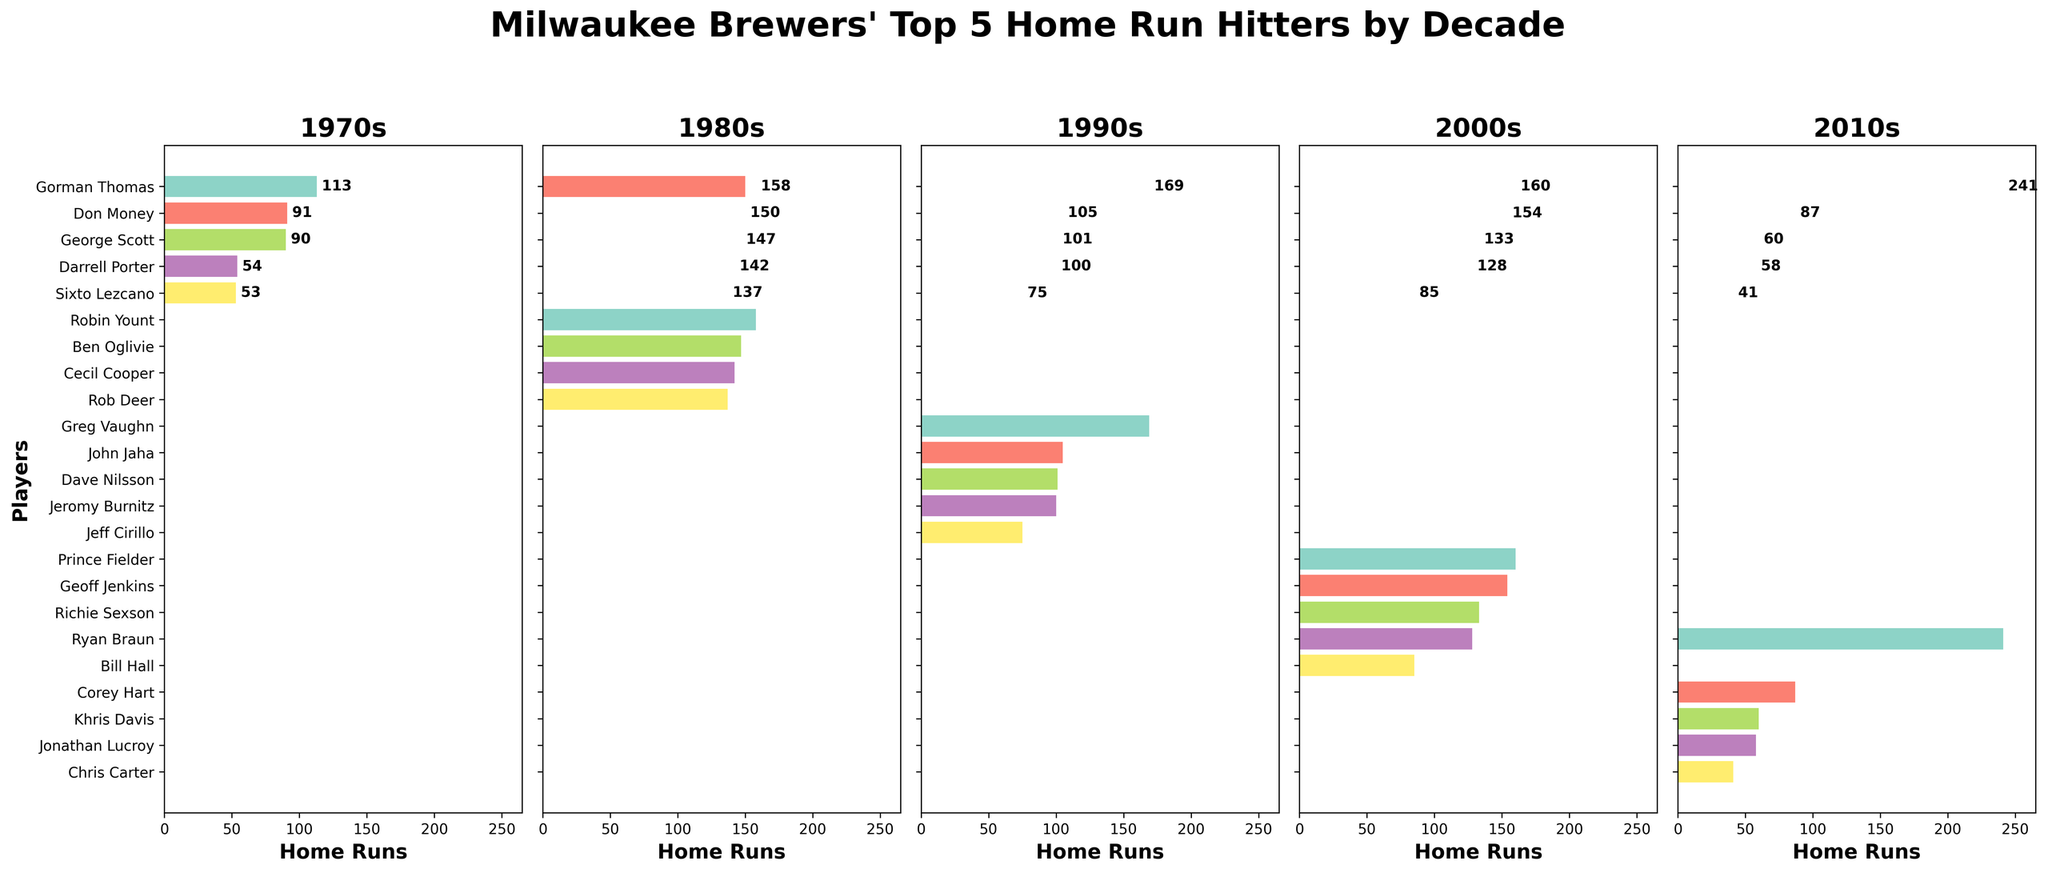Who hit the most home runs in the 1980s? To find this, look at the 1980s section and identify the longest bar or the highest value. Robin Yount hit 158 home runs, which is the highest.
Answer: Robin Yount Which player had the highest number of home runs in the 2010s? Check the 2010s section and find the longest bar or the largest number. Ryan Braun had 241 home runs, the highest in this decade.
Answer: Ryan Braun Who had more home runs in the 2000s: Ryan Braun or Geoff Jenkins? Compare the bars or the numbers for Ryan Braun and Geoff Jenkins in the 2000s section. Ryan Braun had 128 home runs, while Geoff Jenkins had 154.
Answer: Geoff Jenkins How many total home runs did the top 5 players in the 1970s hit? Sum the home run values of the top 5 players in the 1970s: 113 + 91 + 90 + 54 + 53. The total is 401.
Answer: 401 Who hit more home runs in the 1990s: John Jaha or Jeff Cirillo? Look at the home run numbers for John Jaha and Jeff Cirillo in the 1990s section. John Jaha had 105, whereas Jeff Cirillo had 75.
Answer: John Jaha What was the difference in home runs between Gorman Thomas in the 1970s and Gorman Thomas in the 1980s? Compare Gorman Thomas's values for the two decades: 150 (1980s) - 113 (1970s). The difference is 37.
Answer: 37 Who is the only player to appear in the top 5 home run hitters for two consecutive decades? Look for any repeated names across two decades. Gorman Thomas appears in both the 1970s and 1980s.
Answer: Gorman Thomas Who had the second most home runs in the 2000s? In the 2000s section, the second longest bar or the second highest number after the highest. Geoff Jenkins had 154 home runs, the second most.
Answer: Geoff Jenkins How many more home runs did Ryan Braun hit in the 2010s compared to the 2000s? Subtract Ryan Braun’s 2000s home runs from his 2010s home runs: 241 (2010s) - 128 (2000s) = 113.
Answer: 113 Who had more home runs in the 1980s: Ben Oglivie or Cecil Cooper? Check the home run numbers for Ben Oglivie and Cecil Cooper in the 1980s section. Ben Oglivie had 147 and Cecil Cooper had 142.
Answer: Ben Oglivie 